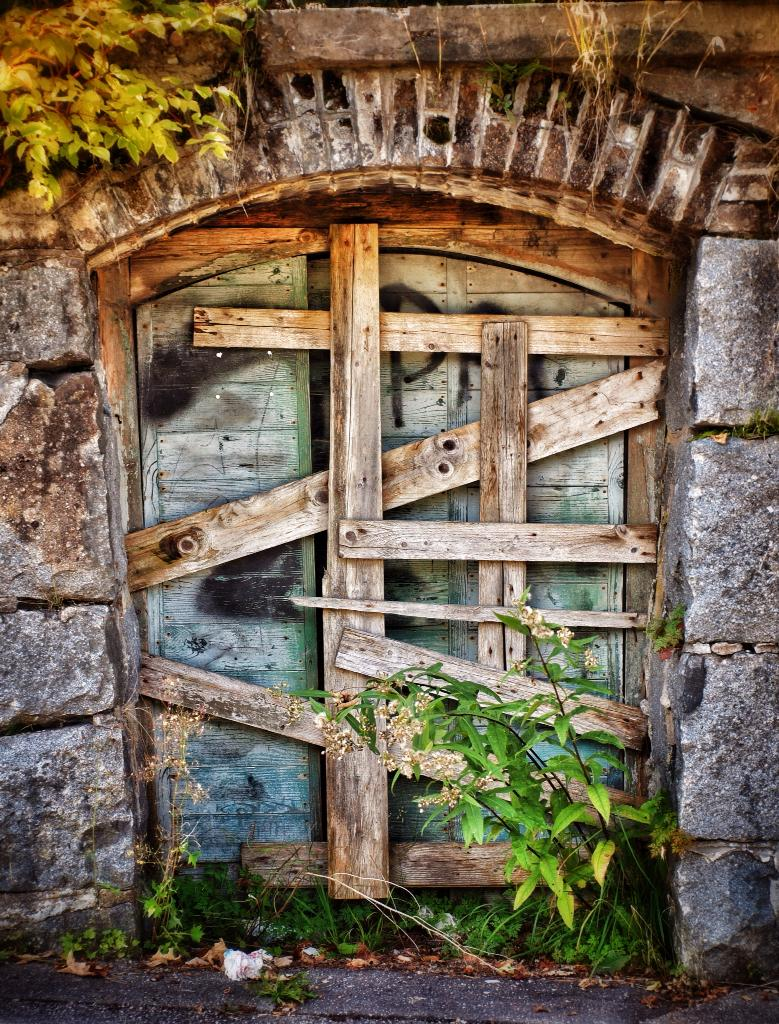What is the main subject in the center of the image? There is a door in the center of the image. What can be seen at the bottom of the image? There are plants at the bottom of the image. What is visible in the background of the image? There are trees in the background of the image. What grade is written on the chalkboard in the image? There is no chalkboard or grade present in the image. What type of calculator is visible on the desk in the image? There is no calculator or desk present in the image. 